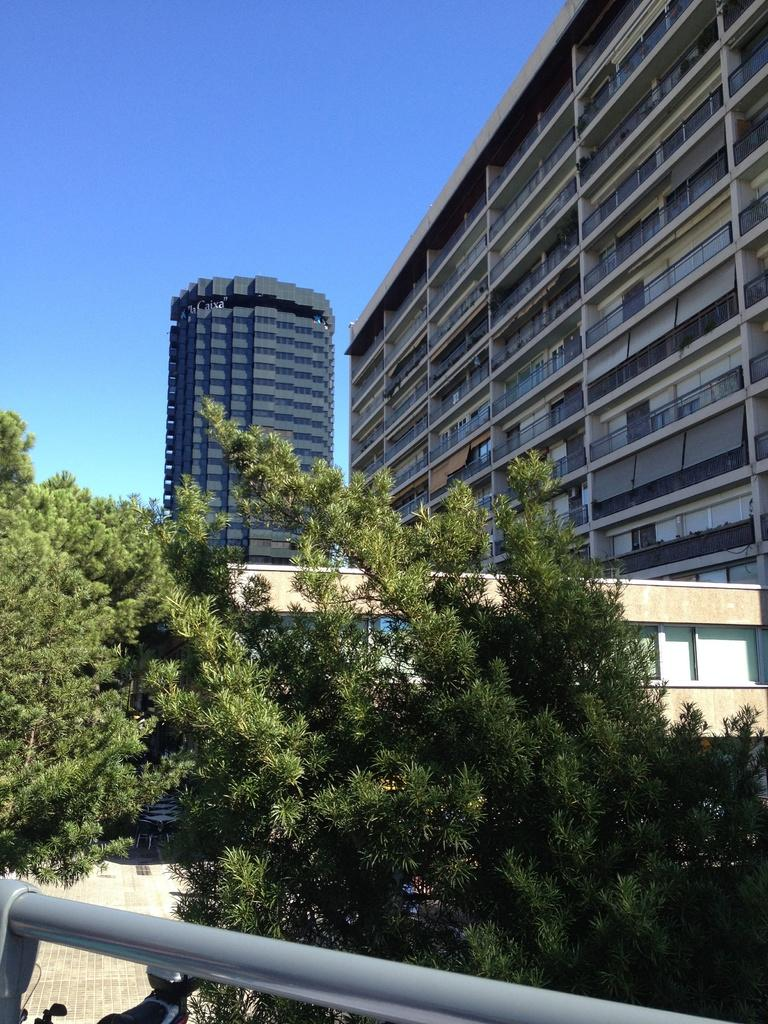What type of natural elements can be seen in the image? There are trees in the image. What is located at the bottom of the image? There is a rod at the bottom of the image. What type of man-made structures are visible in the background of the image? There are buildings in the background of the image. What part of the natural environment is visible in the image? The sky is visible in the image. What type of music can be heard coming from the trees in the image? There is no music present in the image; it is a visual representation of trees and other elements. 